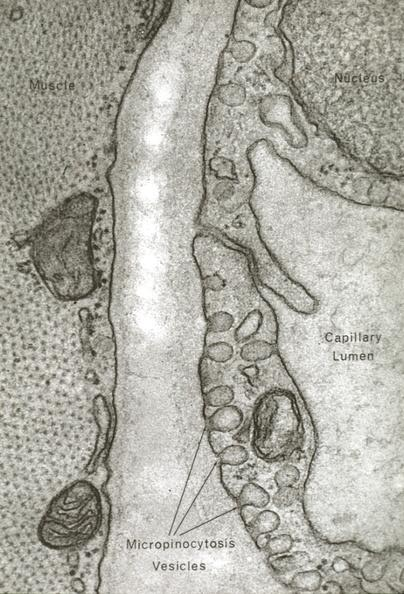what is present?
Answer the question using a single word or phrase. Capillary 